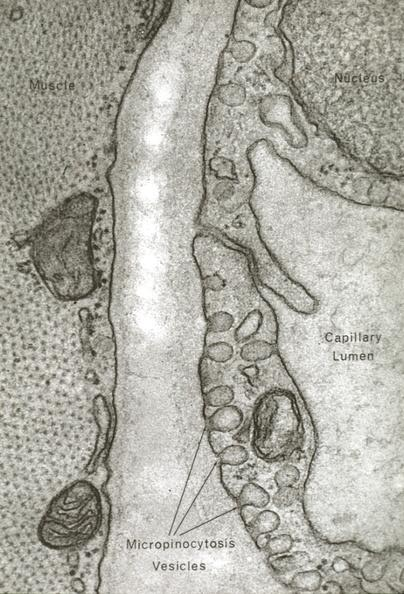what is present?
Answer the question using a single word or phrase. Capillary 